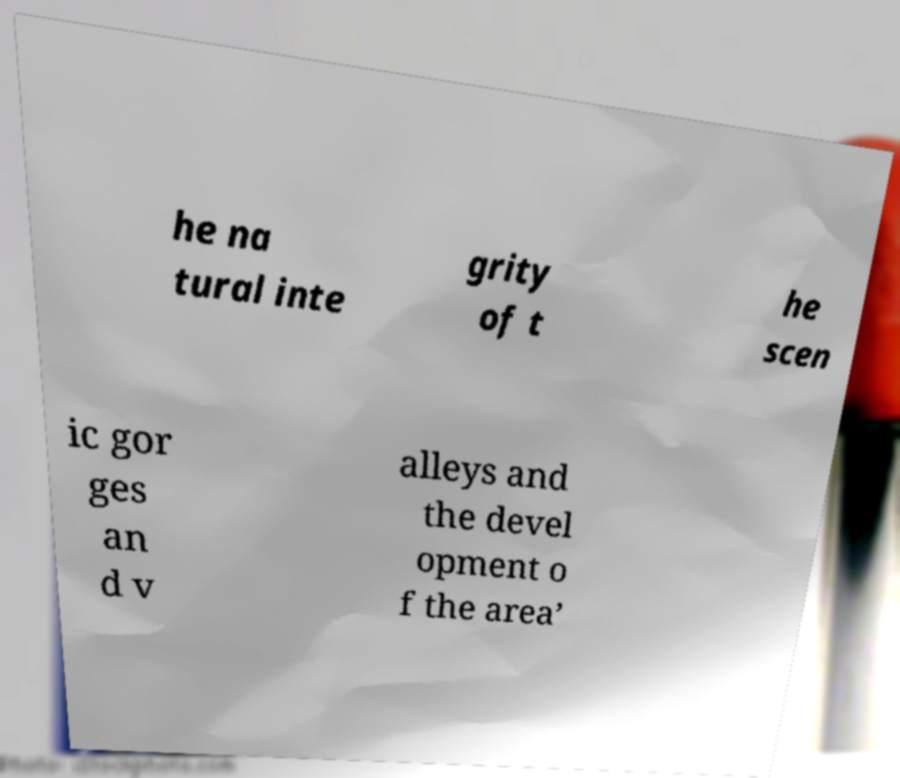Can you accurately transcribe the text from the provided image for me? he na tural inte grity of t he scen ic gor ges an d v alleys and the devel opment o f the area’ 